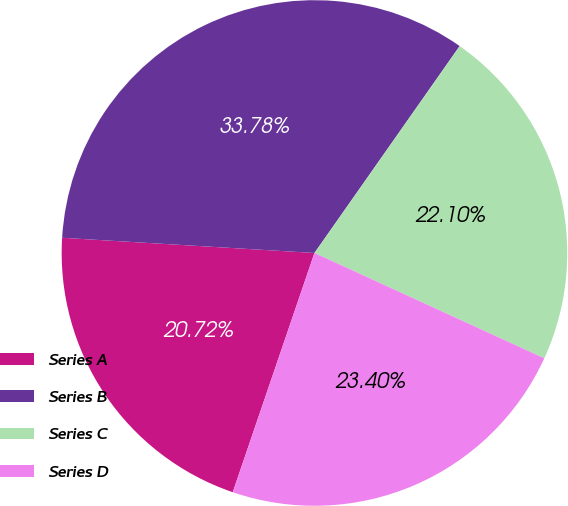<chart> <loc_0><loc_0><loc_500><loc_500><pie_chart><fcel>Series A<fcel>Series B<fcel>Series C<fcel>Series D<nl><fcel>20.72%<fcel>33.78%<fcel>22.1%<fcel>23.4%<nl></chart> 